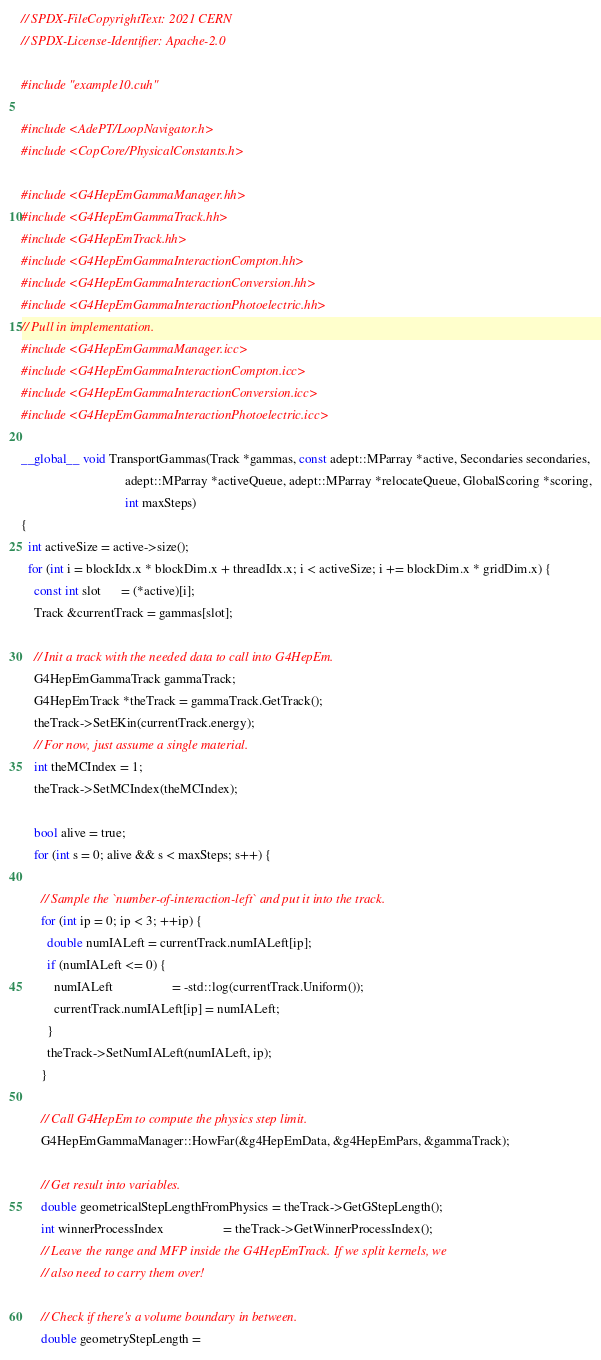<code> <loc_0><loc_0><loc_500><loc_500><_Cuda_>// SPDX-FileCopyrightText: 2021 CERN
// SPDX-License-Identifier: Apache-2.0

#include "example10.cuh"

#include <AdePT/LoopNavigator.h>
#include <CopCore/PhysicalConstants.h>

#include <G4HepEmGammaManager.hh>
#include <G4HepEmGammaTrack.hh>
#include <G4HepEmTrack.hh>
#include <G4HepEmGammaInteractionCompton.hh>
#include <G4HepEmGammaInteractionConversion.hh>
#include <G4HepEmGammaInteractionPhotoelectric.hh>
// Pull in implementation.
#include <G4HepEmGammaManager.icc>
#include <G4HepEmGammaInteractionCompton.icc>
#include <G4HepEmGammaInteractionConversion.icc>
#include <G4HepEmGammaInteractionPhotoelectric.icc>

__global__ void TransportGammas(Track *gammas, const adept::MParray *active, Secondaries secondaries,
                                adept::MParray *activeQueue, adept::MParray *relocateQueue, GlobalScoring *scoring,
                                int maxSteps)
{
  int activeSize = active->size();
  for (int i = blockIdx.x * blockDim.x + threadIdx.x; i < activeSize; i += blockDim.x * gridDim.x) {
    const int slot      = (*active)[i];
    Track &currentTrack = gammas[slot];

    // Init a track with the needed data to call into G4HepEm.
    G4HepEmGammaTrack gammaTrack;
    G4HepEmTrack *theTrack = gammaTrack.GetTrack();
    theTrack->SetEKin(currentTrack.energy);
    // For now, just assume a single material.
    int theMCIndex = 1;
    theTrack->SetMCIndex(theMCIndex);

    bool alive = true;
    for (int s = 0; alive && s < maxSteps; s++) {

      // Sample the `number-of-interaction-left` and put it into the track.
      for (int ip = 0; ip < 3; ++ip) {
        double numIALeft = currentTrack.numIALeft[ip];
        if (numIALeft <= 0) {
          numIALeft                  = -std::log(currentTrack.Uniform());
          currentTrack.numIALeft[ip] = numIALeft;
        }
        theTrack->SetNumIALeft(numIALeft, ip);
      }

      // Call G4HepEm to compute the physics step limit.
      G4HepEmGammaManager::HowFar(&g4HepEmData, &g4HepEmPars, &gammaTrack);

      // Get result into variables.
      double geometricalStepLengthFromPhysics = theTrack->GetGStepLength();
      int winnerProcessIndex                  = theTrack->GetWinnerProcessIndex();
      // Leave the range and MFP inside the G4HepEmTrack. If we split kernels, we
      // also need to carry them over!

      // Check if there's a volume boundary in between.
      double geometryStepLength =</code> 